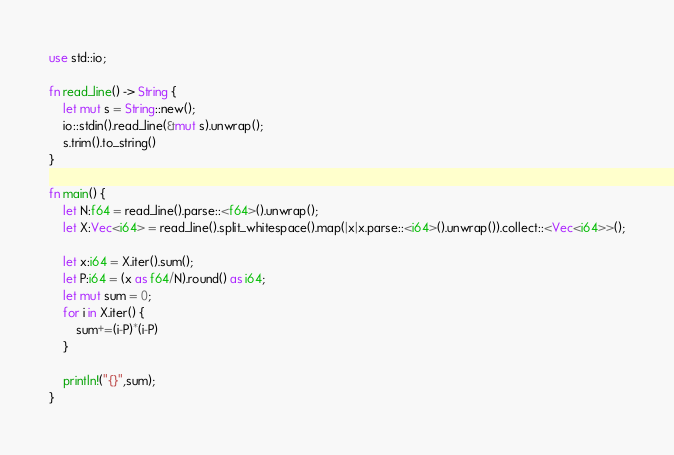<code> <loc_0><loc_0><loc_500><loc_500><_Rust_>use std::io;

fn read_line() -> String {
    let mut s = String::new();
    io::stdin().read_line(&mut s).unwrap();
    s.trim().to_string()
}

fn main() {
    let N:f64 = read_line().parse::<f64>().unwrap();
    let X:Vec<i64> = read_line().split_whitespace().map(|x|x.parse::<i64>().unwrap()).collect::<Vec<i64>>();
    
    let x:i64 = X.iter().sum();
    let P:i64 = (x as f64/N).round() as i64; 
    let mut sum = 0;
    for i in X.iter() {
        sum+=(i-P)*(i-P)
    }

    println!("{}",sum);
}</code> 